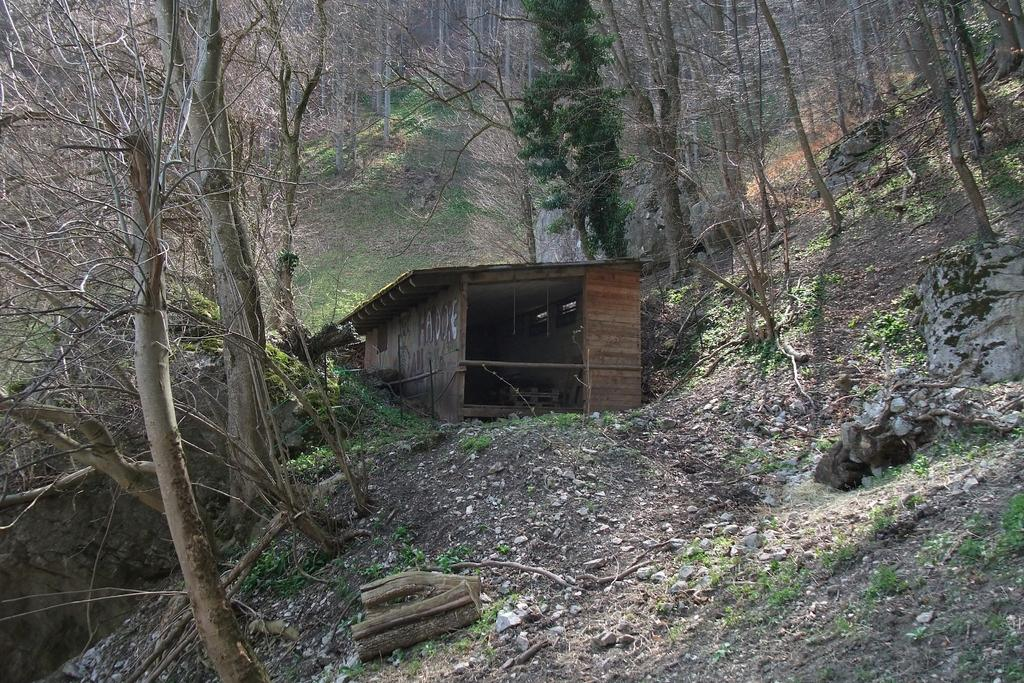What type of vegetation can be seen in the image? There are trees in the image. What type of structure is present in the image? There is a wooden house in the image. Can you tell me how many donkeys are grazing near the wooden house in the image? There is no donkey present in the image; it only features trees and a wooden house. What type of system or engine is powering the wooden house in the image? The image does not provide information about any system or engine powering the wooden house, as it only shows the structure itself. 